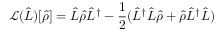Convert formula to latex. <formula><loc_0><loc_0><loc_500><loc_500>\mathcal { L } ( \hat { L } ) [ \hat { \rho } ] = \hat { L } \hat { \rho } \hat { L } ^ { \dag } - \frac { 1 } { 2 } ( \hat { L } ^ { \dag } \hat { L } \hat { \rho } + \hat { \rho } \hat { L } ^ { \dag } \hat { L } )</formula> 